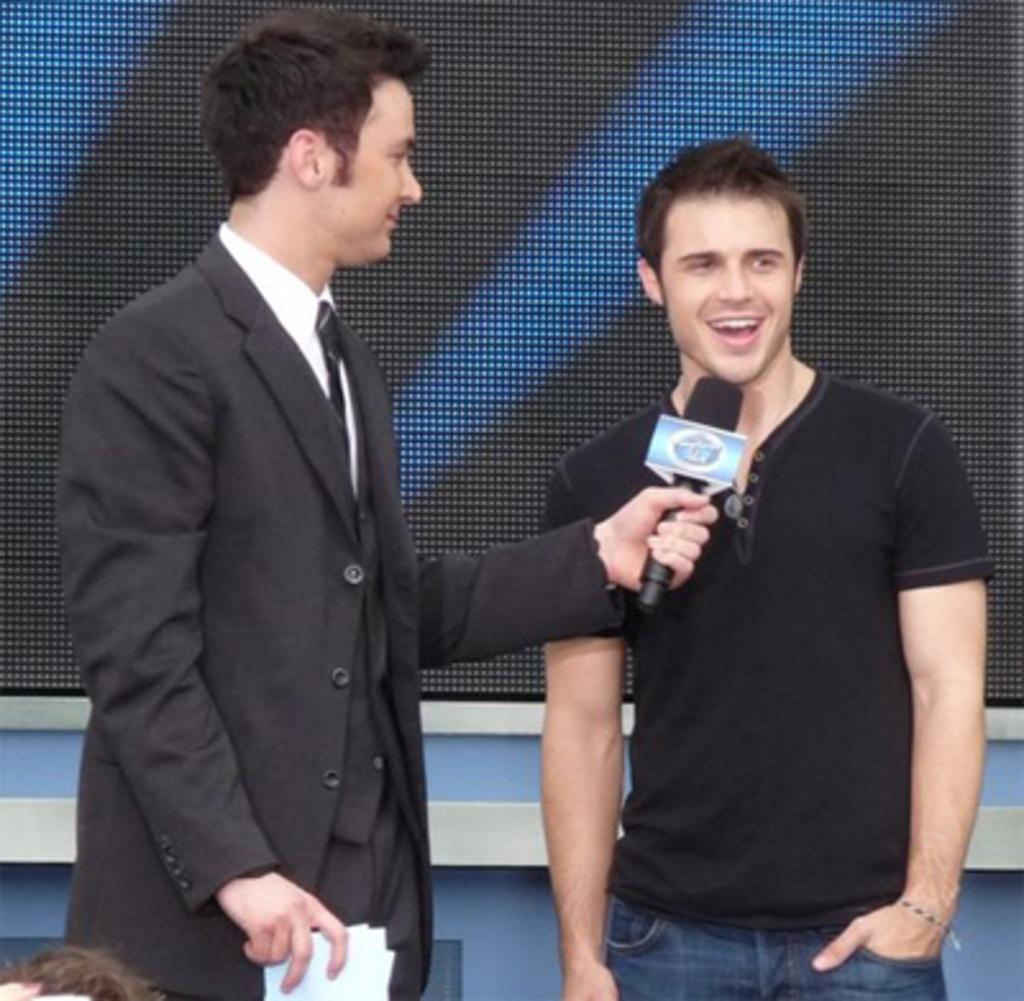How many people are in the image? There are two men in the image. What is one of the men holding? One of the men is holding a microphone. What else is the man with the microphone holding? The man with the microphone is also holding papers in his hands. What type of arch can be seen in the background of the image? There is no arch present in the image. Is the man with the microphone also holding a notebook? The provided facts do not mention a notebook, so it cannot be determined if the man is holding one. 